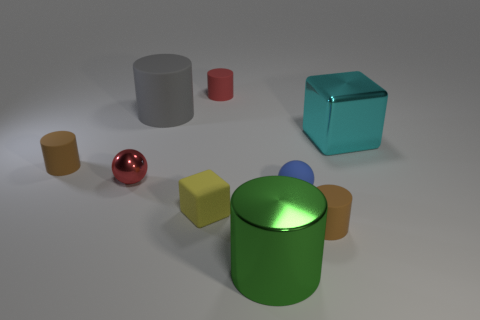Subtract 2 cylinders. How many cylinders are left? 3 Subtract all red cylinders. How many cylinders are left? 4 Subtract all large rubber cylinders. How many cylinders are left? 4 Subtract all yellow cylinders. Subtract all green blocks. How many cylinders are left? 5 Add 1 tiny brown things. How many objects exist? 10 Subtract all cylinders. How many objects are left? 4 Subtract 0 blue blocks. How many objects are left? 9 Subtract all small red blocks. Subtract all large green shiny cylinders. How many objects are left? 8 Add 2 red matte things. How many red matte things are left? 3 Add 9 green rubber things. How many green rubber things exist? 9 